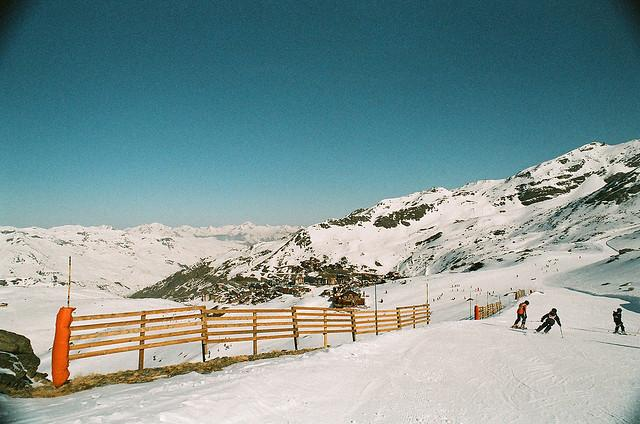What use is the fencing shown here?

Choices:
A) boundary guideline
B) decorative
C) livestock containment
D) crop protection boundary guideline 